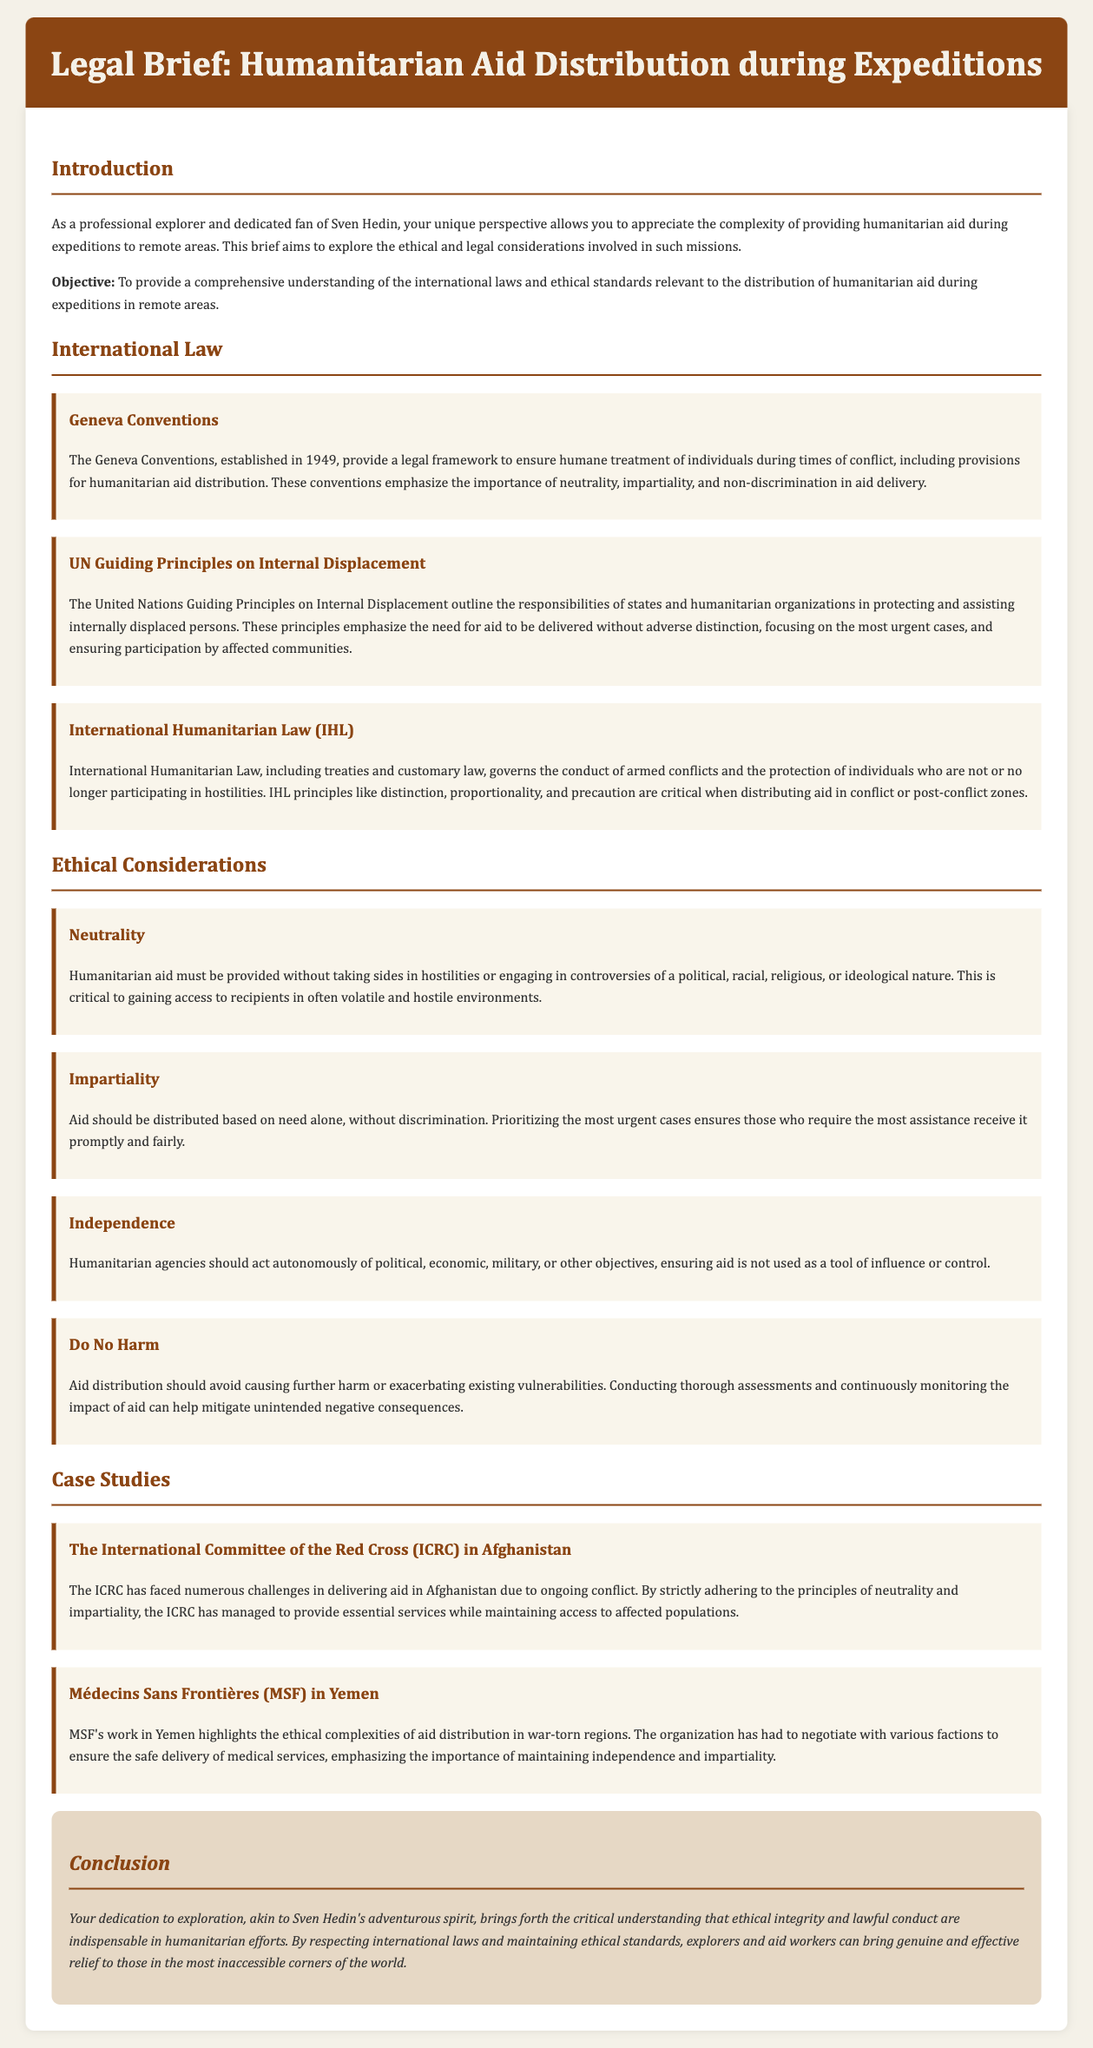What are the Geneva Conventions? The Geneva Conventions are a set of treaties that provide a legal framework to ensure humane treatment of individuals during times of conflict, including provisions for humanitarian aid distribution.
Answer: A set of treaties What is the primary objective of this legal brief? The primary objective as stated in the brief is to provide a comprehensive understanding of the international laws and ethical standards relevant to the distribution of humanitarian aid.
Answer: Comprehensive understanding What principle emphasizes the need for neutrality in aid delivery? The principle that emphasizes the need for neutrality in aid delivery is outlined under Ethical Considerations, specifically focusing on not taking sides in hostilities.
Answer: Neutrality Which organization faced challenges delivering aid in Afghanistan? The organization that faced challenges delivering aid in Afghanistan, while adhering to principles of neutrality and impartiality is the International Committee of the Red Cross.
Answer: International Committee of the Red Cross What ethical principle is highlighted to avoid exacerbating vulnerabilities? The ethical principle highlighted to avoid exacerbating vulnerabilities is "Do No Harm."
Answer: Do No Harm How many key documents related to International Law does the brief mention? The brief mentions three key documents related to International Law.
Answer: Three What does International Humanitarian Law (IHL) govern? International Humanitarian Law (IHL) governs the conduct of armed conflicts and the protection of individuals who are not or no longer participating in hostilities.
Answer: Conduct of armed conflicts What was a significant challenge for Médecins Sans Frontières in Yemen? A significant challenge for Médecins Sans Frontières in Yemen was negotiating with various factions to ensure the safe delivery of medical services.
Answer: Negotiating with factions What is the main theme of the conclusion section? The main theme of the conclusion section is that ethical integrity and lawful conduct are indispensable in humanitarian efforts.
Answer: Ethical integrity and lawful conduct 